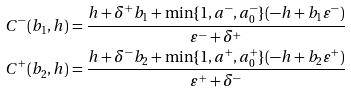<formula> <loc_0><loc_0><loc_500><loc_500>C ^ { - } ( b _ { 1 } , h ) = \frac { h + \delta ^ { + } b _ { 1 } + \min \{ 1 , a ^ { - } , a ^ { - } _ { 0 } \} ( - h + b _ { 1 } \varepsilon ^ { - } ) } { \varepsilon ^ { - } + \delta ^ { + } } \\ C ^ { + } ( b _ { 2 } , h ) = \frac { h + \delta ^ { - } b _ { 2 } + \min \{ 1 , a ^ { + } , a ^ { + } _ { 0 } \} ( - h + b _ { 2 } \varepsilon ^ { + } ) } { \varepsilon ^ { + } + \delta ^ { - } }</formula> 